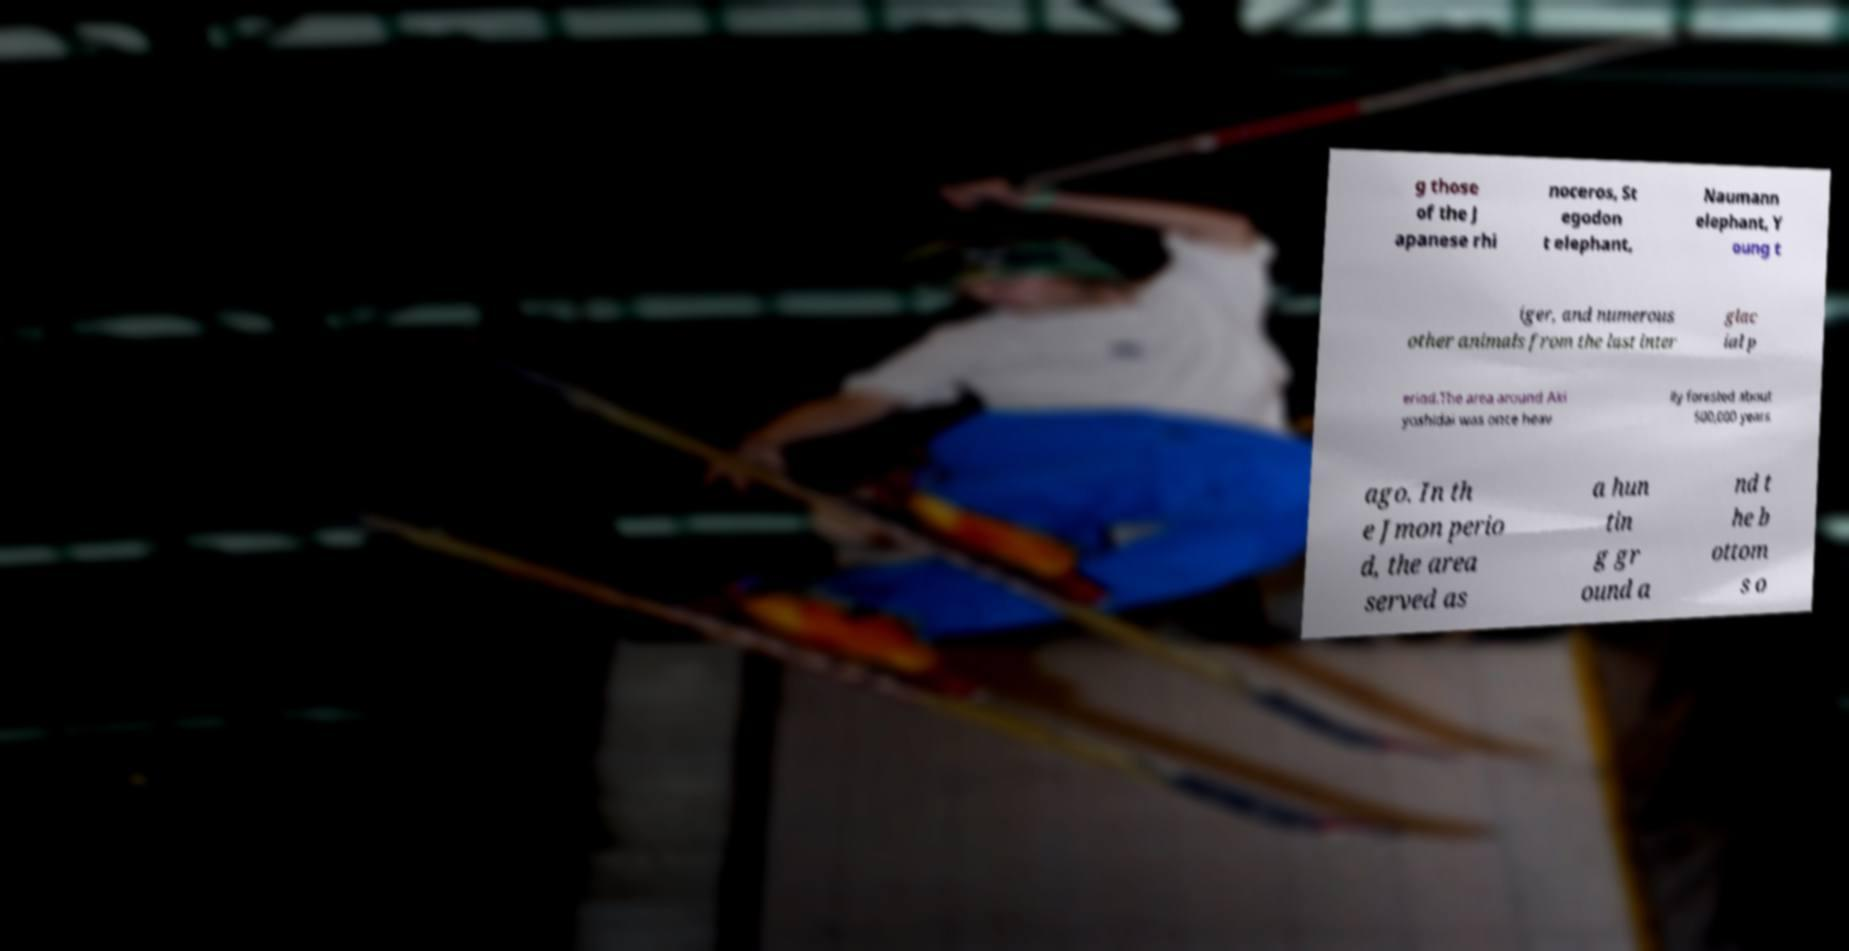Could you assist in decoding the text presented in this image and type it out clearly? g those of the J apanese rhi noceros, St egodon t elephant, Naumann elephant, Y oung t iger, and numerous other animals from the last inter glac ial p eriod.The area around Aki yoshidai was once heav ily forested about 500,000 years ago. In th e Jmon perio d, the area served as a hun tin g gr ound a nd t he b ottom s o 